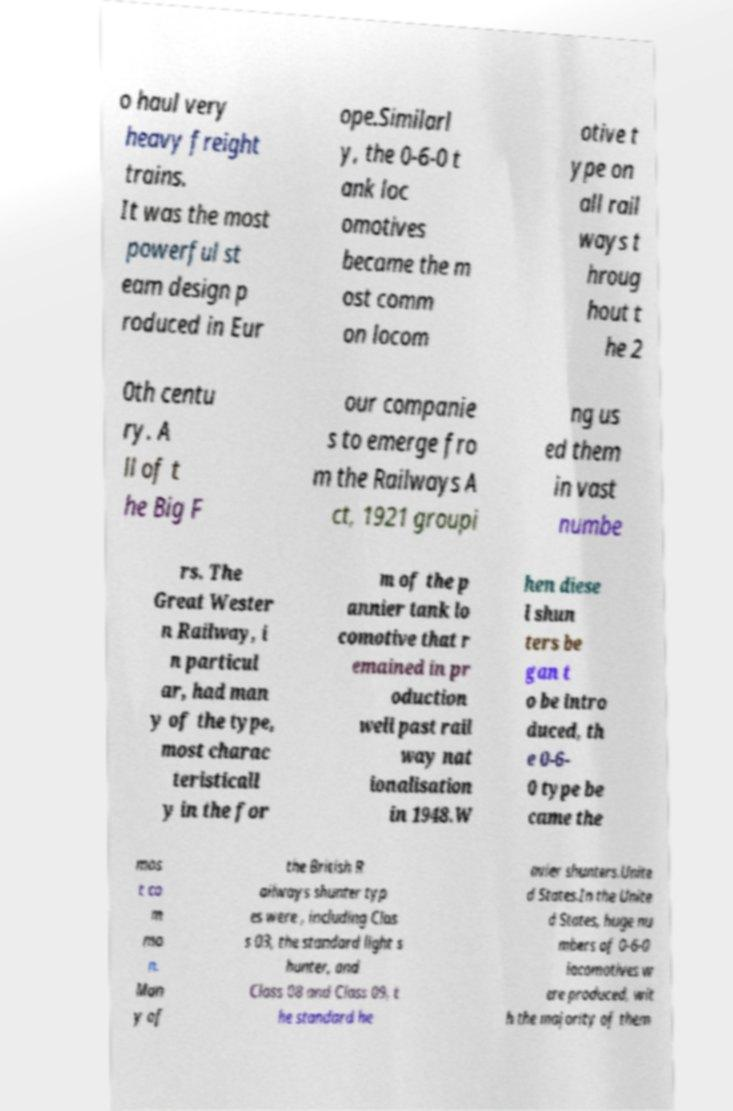Could you assist in decoding the text presented in this image and type it out clearly? o haul very heavy freight trains. It was the most powerful st eam design p roduced in Eur ope.Similarl y, the 0-6-0 t ank loc omotives became the m ost comm on locom otive t ype on all rail ways t hroug hout t he 2 0th centu ry. A ll of t he Big F our companie s to emerge fro m the Railways A ct, 1921 groupi ng us ed them in vast numbe rs. The Great Wester n Railway, i n particul ar, had man y of the type, most charac teristicall y in the for m of the p annier tank lo comotive that r emained in pr oduction well past rail way nat ionalisation in 1948.W hen diese l shun ters be gan t o be intro duced, th e 0-6- 0 type be came the mos t co m mo n. Man y of the British R ailways shunter typ es were , including Clas s 03, the standard light s hunter, and Class 08 and Class 09, t he standard he avier shunters.Unite d States.In the Unite d States, huge nu mbers of 0-6-0 locomotives w ere produced, wit h the majority of them 